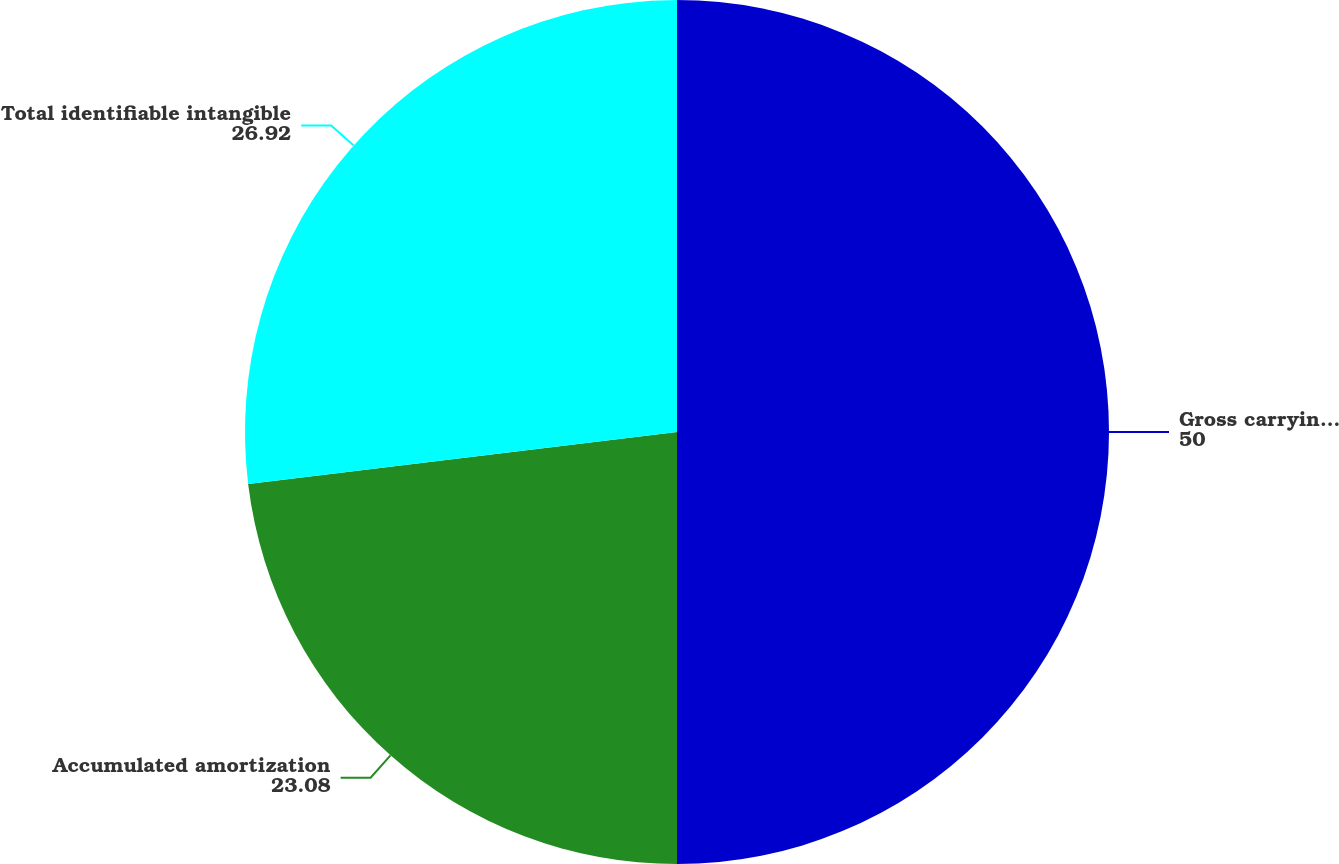<chart> <loc_0><loc_0><loc_500><loc_500><pie_chart><fcel>Gross carrying amount<fcel>Accumulated amortization<fcel>Total identifiable intangible<nl><fcel>50.0%<fcel>23.08%<fcel>26.92%<nl></chart> 